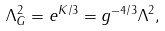<formula> <loc_0><loc_0><loc_500><loc_500>\Lambda ^ { 2 } _ { G } = e ^ { K / 3 } = g ^ { - 4 / 3 } \Lambda ^ { 2 } ,</formula> 